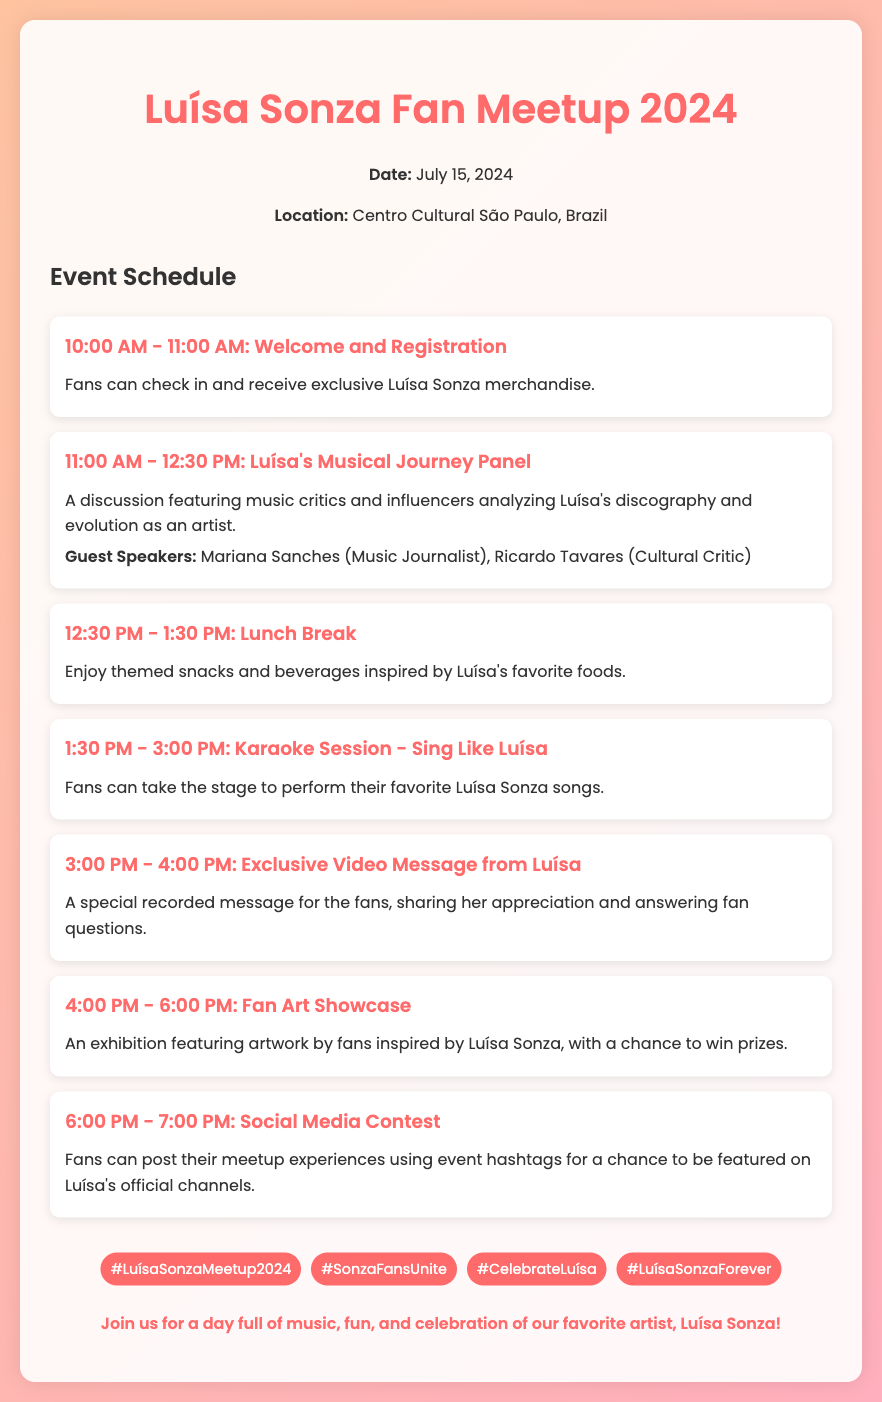What is the date of the event? The date of the event is explicitly mentioned in the document as July 15, 2024.
Answer: July 15, 2024 Where is the meetup taking place? The location of the event is stated in the document as Centro Cultural São Paulo, Brazil.
Answer: Centro Cultural São Paulo, Brazil Who are the guest speakers for the panel discussion? The document lists the guest speakers for the panel as Mariana Sanches and Ricardo Tavares.
Answer: Mariana Sanches, Ricardo Tavares What activity occurs from 1:30 PM to 3:00 PM? The document specifies that a Karaoke Session - Sing Like Luísa takes place during this time.
Answer: Karaoke Session - Sing Like Luísa What is featured in the social media contest? The social media contest encourages fans to post their meetup experiences using specific hashtags.
Answer: Meetup experiences using event hashtags How long is the lunch break scheduled for? The document states the lunch break is scheduled for one hour, from 12:30 PM to 1:30 PM.
Answer: 1 hour What type of showcase is featured at 4:00 PM? The document mentions a Fan Art Showcase, which consists of artwork inspired by Luísa Sonza.
Answer: Fan Art Showcase How many hashtags are provided for the event? The document lists four different hashtags for promoting the event on social media.
Answer: Four 